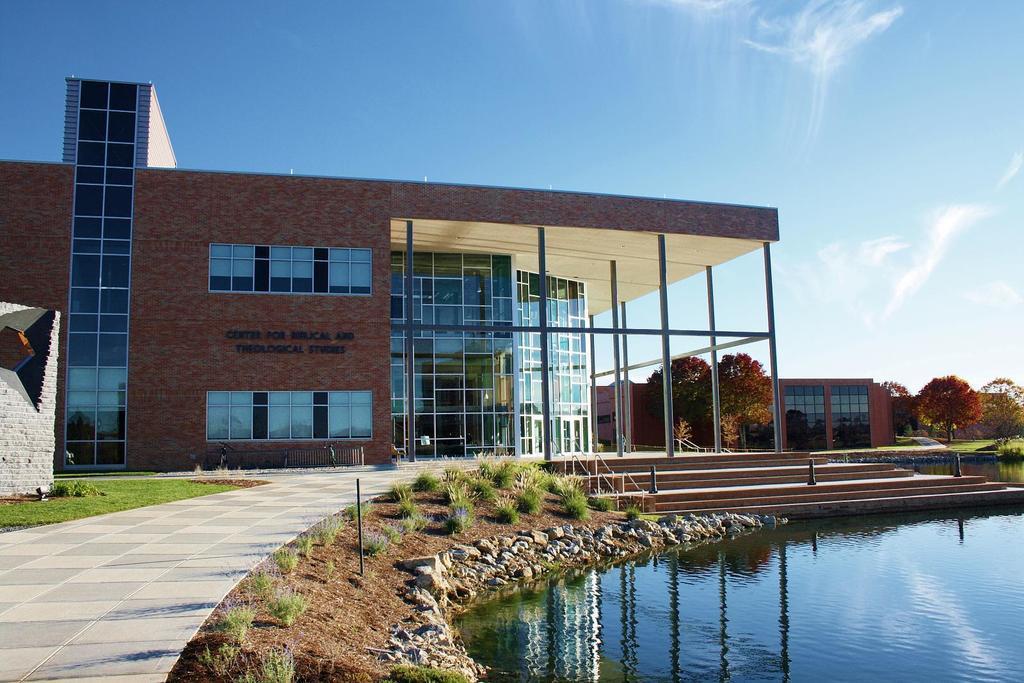Could you give a brief overview of what you see in this image? In this image we can see two buildings, there we can see grass, stones, water, stairs, fences, small poles, few people, trees and the sky. 